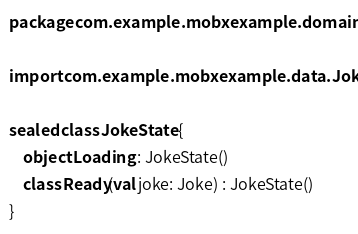Convert code to text. <code><loc_0><loc_0><loc_500><loc_500><_Kotlin_>package com.example.mobxexample.domain

import com.example.mobxexample.data.Joke

sealed class JokeState {
    object Loading : JokeState()
    class Ready(val joke: Joke) : JokeState()
}
</code> 